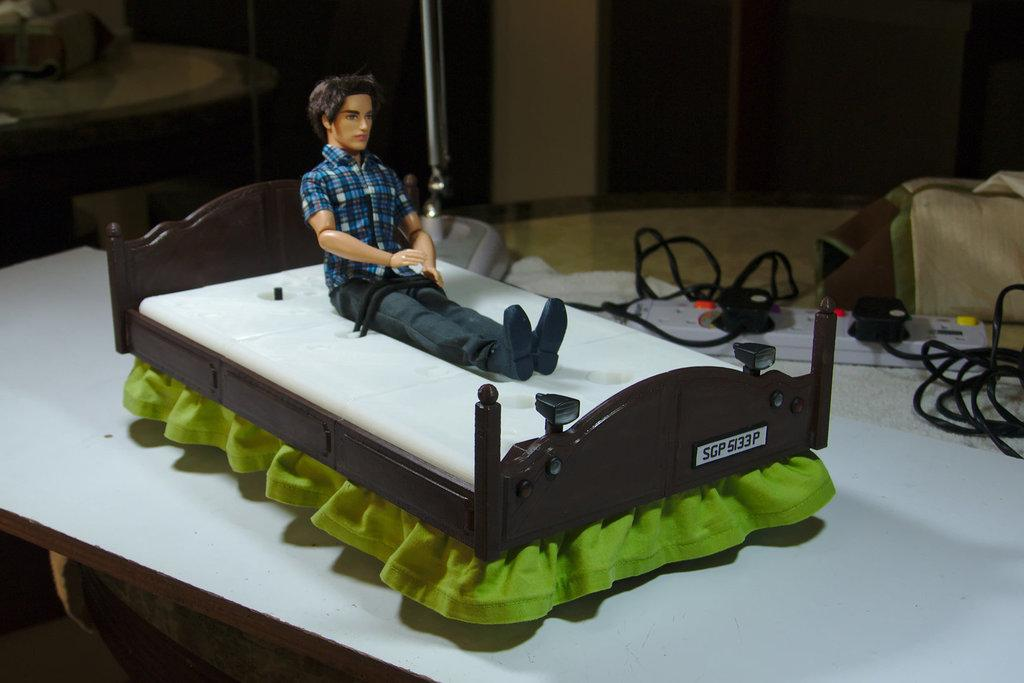What is the main subject of the image? The main subject of the image is a toy bed. What is placed on the toy bed? There is a doll of a boy on the toy bed. What else can be seen in the image besides the toy bed and the doll? There are wires and an extension board visible in the image. What type of acoustics can be heard coming from the cap in the image? There is no cap present in the image, so it's not possible to determine what, if any, acoustics might be heard. 